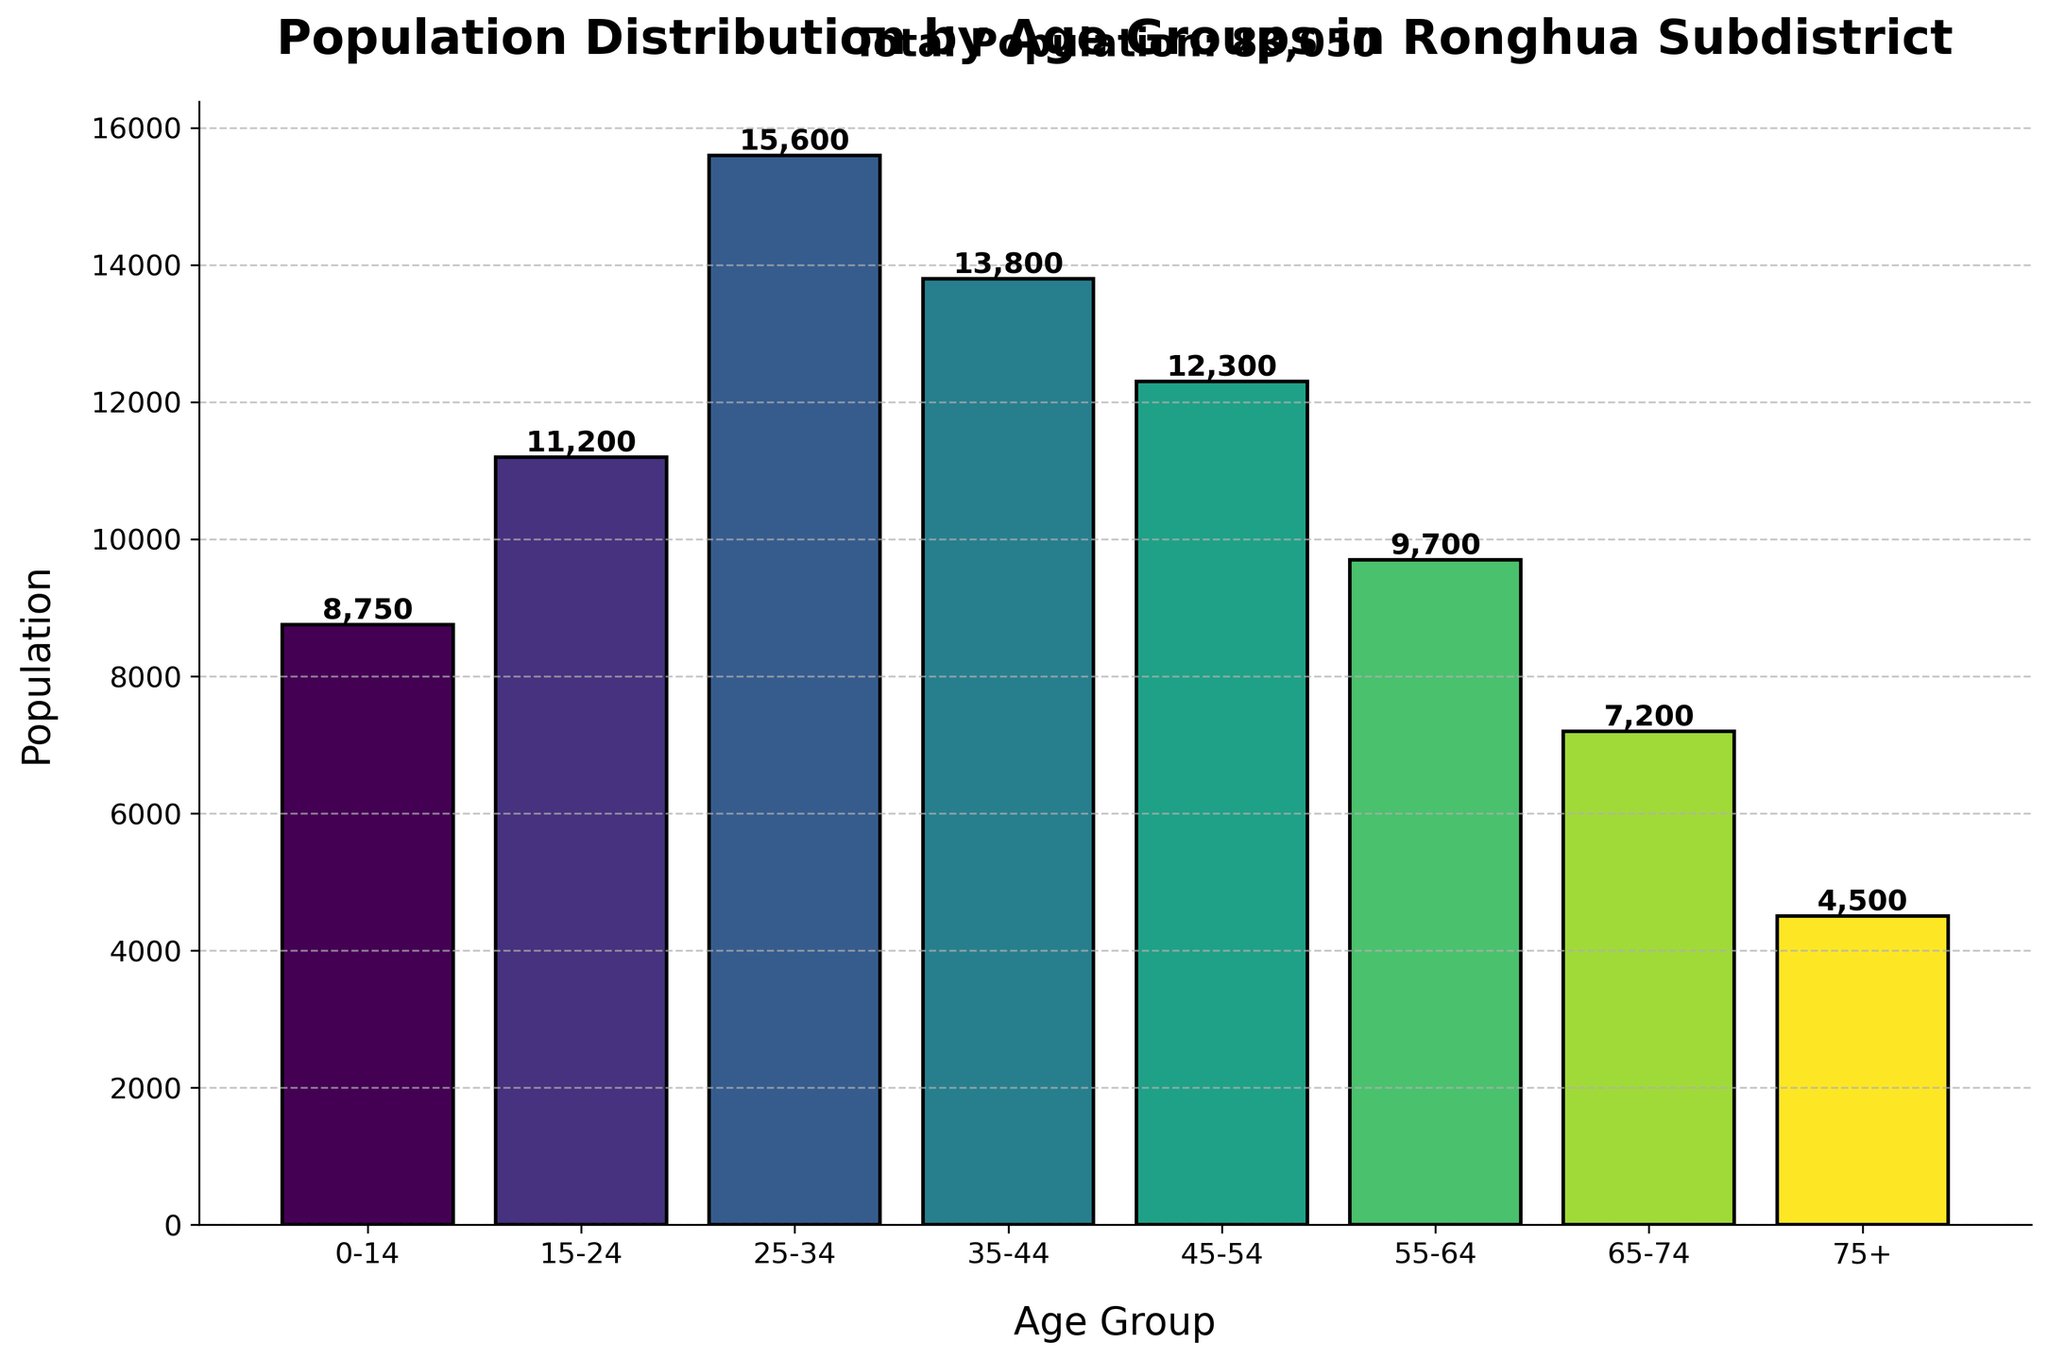What is the total population of Ronghua Subdistrict? Sum up the population in all age groups: 8750 + 11200 + 15600 + 13800 + 12300 + 9700 + 7200 + 4500 = 83050
Answer: 83050 Which age group has the highest population? Identify the age group with the largest population value. The 25-34 group has the highest population of 15600, which is the tallest bar in the chart.
Answer: 25-34 What is the difference in population between the 25-34 and 75+ age groups? Subtract the population of the 75+ group from the 25-34 group: 15600 - 4500 = 11100
Answer: 11100 How many more people are in the 35-44 age group compared to the 55-64 age group? Subtract the population of the 55-64 group from the 35-44 group: 13800 - 9700 = 4100
Answer: 4100 What is the average population of all age groups? Sum all the populations and divide by the number of age groups: (8750 + 11200 + 15600 + 13800 + 12300 + 9700 + 7200 + 4500) / 8 = 10381.25
Answer: 10381.25 Which age group has the second smallest population? Identify the smallest and second smallest populations. The smallest is 75+ with 4500, and the second smallest is 65-74 with 7200
Answer: 65-74 What is the sum of the population for age groups under 25? Add the populations of the 0-14 and 15-24 age groups: 8750 + 11200 = 19950
Answer: 19950 What percentage of the total population is in the 45-54 age group? Calculate the percentage: (12300 / 83050) * 100 ≈ 14.82%
Answer: 14.82% How does the population of the 45-54 age group compare to that of the 0-14 age group? Subtract the population of the 0-14 group from the 45-54 group: 12300 - 8750 = 3550. The 45-54 group has 3550 more people than the 0-14 group.
Answer: 3550 more Describe the color transition of the bars in the chart. The colors of the bars transition smoothly from lighter shades to darker shades as the population increases, with greenish shades being prominent.
Answer: Greenish shades 